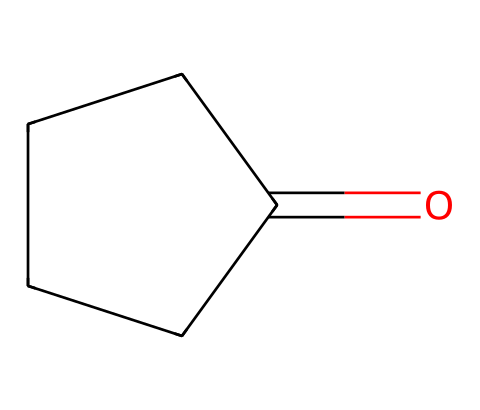What is the name of this cycloalkane? The molecular structure corresponds to a five-membered cyclic ketone, which is known as cyclopentanone. The "cyclo" prefix indicates it's a cyclic compound, and the "pentanone" specifies the presence of five carbon atoms with a ketone functional group.
Answer: cyclopentanone How many carbon atoms are in cyclopentanone? By analyzing the SMILES representation "O=C1CCCC1," we identify a total of five carbon atoms within the ring structure and the ketone carbon. The 'C' letters indicate each carbon atom.
Answer: five What type of functional group is present in cyclopentanone? In the SMILES notation, the "O=" signifies a ketone functional group, where a carbon atom is double bonded to an oxygen atom. This is characteristic of ketones, which differentiate them from other types of carbonyl compounds.
Answer: ketone What is the total number of hydrogen atoms in cyclopentanone? To deduce the number of hydrogen atoms, we can use the general formula for cycloalkanes, which is CnH2n. Since there are five carbon atoms (n=5), applying the formula gives H=10. However, because one carbon is double-bonded to oxygen, two hydrogen atoms are replaced, resulting in eight hydrogen atoms.
Answer: eight Is cyclopentanone a saturated compound? Cyclopentanone possesses a double bond (in the carbonyl group) which creates unsaturation, making it an unsaturated compound. Saturated compounds contain only single bonds, while cyclopentanone contains one double bond, thus it does not qualify as saturated.
Answer: no What is the bond angle in cyclopentanone? In cycloalkanes, the bond angles tend to be close to 109.5 degrees due to the tetrahedral geometry around sp3 hybridized carbon atoms. Cyclopentanone, being a cyclic structure with five carbon atoms, will have bond angles that approximate this ideal tetrahedral angle.
Answer: approximately 109.5 degrees 